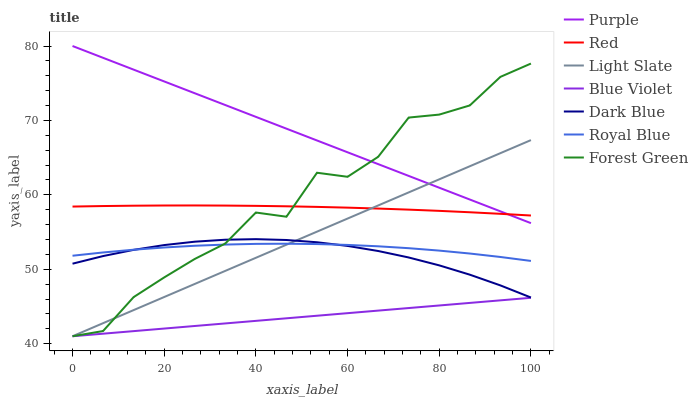Does Blue Violet have the minimum area under the curve?
Answer yes or no. Yes. Does Purple have the maximum area under the curve?
Answer yes or no. Yes. Does Light Slate have the minimum area under the curve?
Answer yes or no. No. Does Light Slate have the maximum area under the curve?
Answer yes or no. No. Is Light Slate the smoothest?
Answer yes or no. Yes. Is Forest Green the roughest?
Answer yes or no. Yes. Is Purple the smoothest?
Answer yes or no. No. Is Purple the roughest?
Answer yes or no. No. Does Purple have the lowest value?
Answer yes or no. No. Does Purple have the highest value?
Answer yes or no. Yes. Does Light Slate have the highest value?
Answer yes or no. No. Is Dark Blue less than Purple?
Answer yes or no. Yes. Is Purple greater than Blue Violet?
Answer yes or no. Yes. Does Royal Blue intersect Light Slate?
Answer yes or no. Yes. Is Royal Blue less than Light Slate?
Answer yes or no. No. Is Royal Blue greater than Light Slate?
Answer yes or no. No. Does Dark Blue intersect Purple?
Answer yes or no. No. 